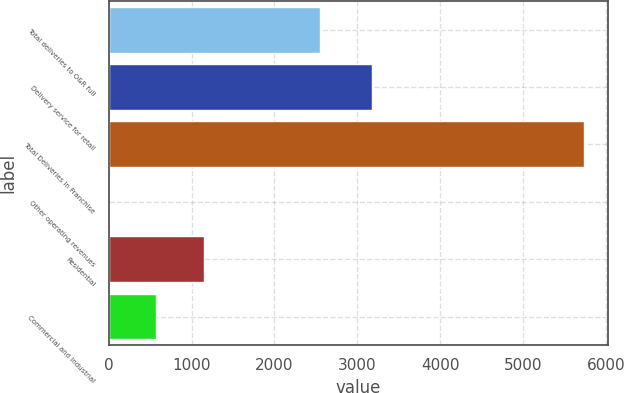<chart> <loc_0><loc_0><loc_500><loc_500><bar_chart><fcel>Total deliveries to O&R full<fcel>Delivery service for retail<fcel>Total Deliveries In Franchise<fcel>Other operating revenues<fcel>Residential<fcel>Commercial and Industrial<nl><fcel>2555<fcel>3180<fcel>5735<fcel>2<fcel>1148.6<fcel>575.3<nl></chart> 